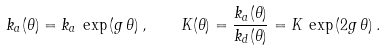Convert formula to latex. <formula><loc_0><loc_0><loc_500><loc_500>k _ { a } ( \theta ) = k _ { a } \, \exp \left ( g \, \theta \right ) , \quad K ( \theta ) = \frac { k _ { a } ( \theta ) } { k _ { d } ( \theta ) } = K \, \exp \left ( 2 g \, \theta \right ) .</formula> 